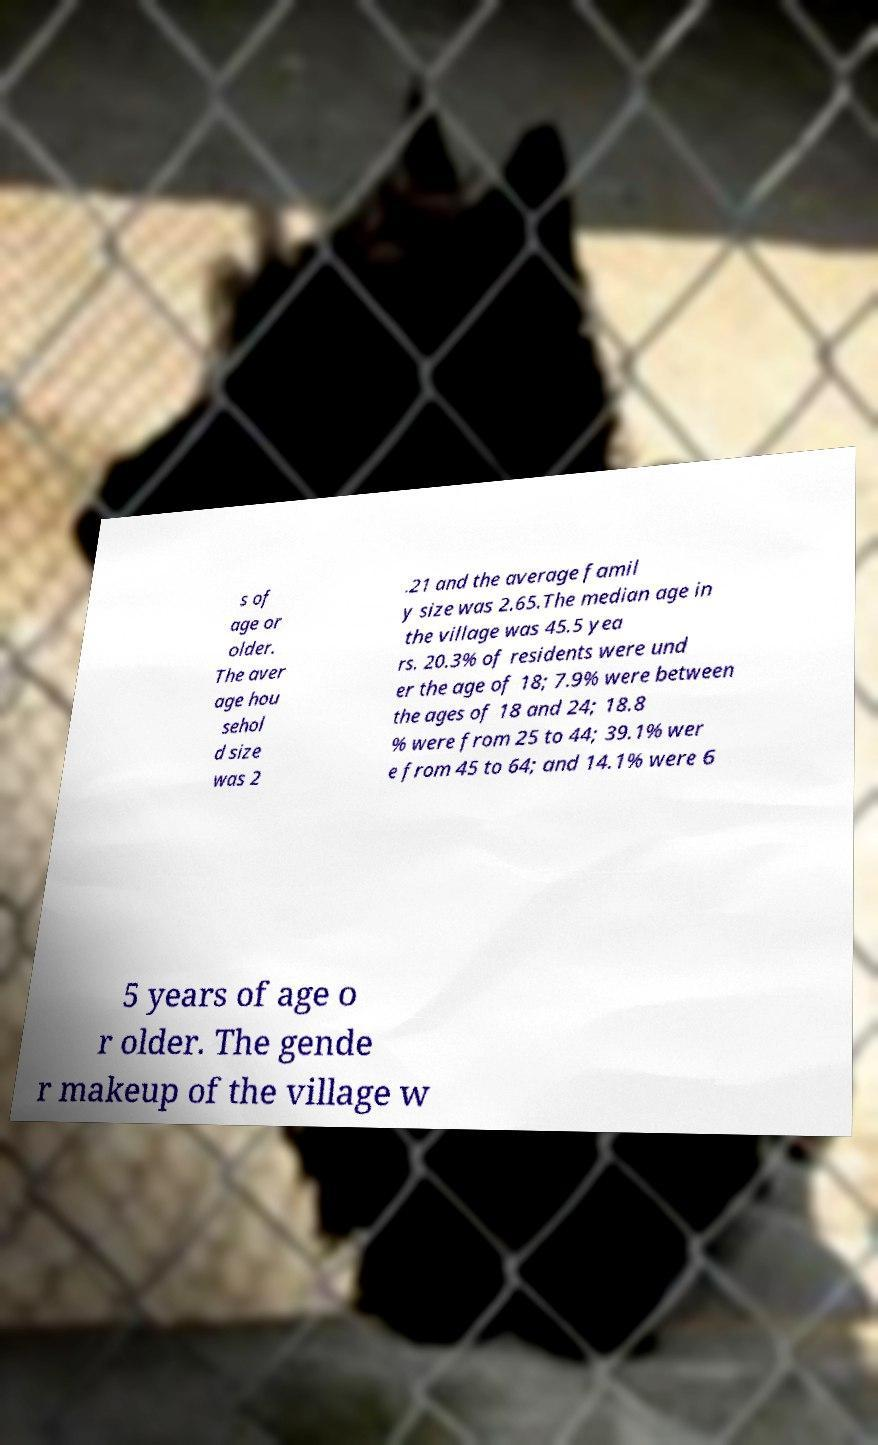Can you read and provide the text displayed in the image?This photo seems to have some interesting text. Can you extract and type it out for me? s of age or older. The aver age hou sehol d size was 2 .21 and the average famil y size was 2.65.The median age in the village was 45.5 yea rs. 20.3% of residents were und er the age of 18; 7.9% were between the ages of 18 and 24; 18.8 % were from 25 to 44; 39.1% wer e from 45 to 64; and 14.1% were 6 5 years of age o r older. The gende r makeup of the village w 